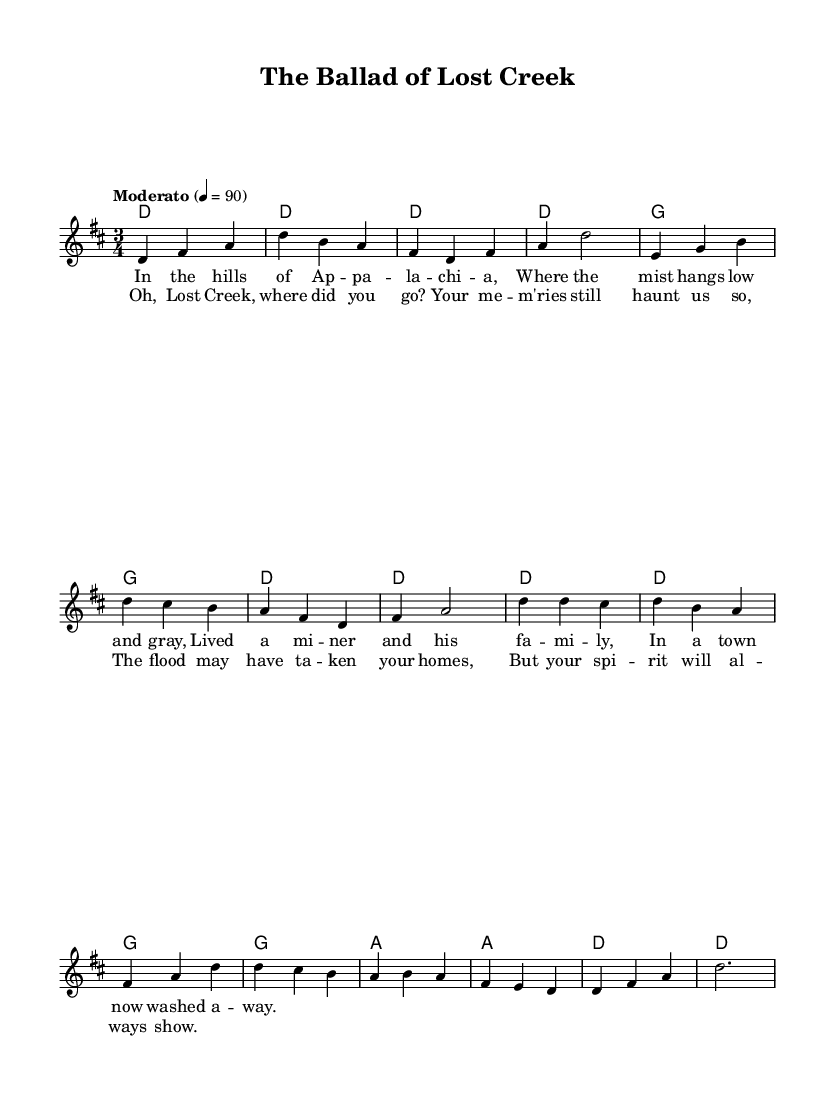What is the key signature of this music? The key signature is indicated at the beginning of the staff. It shows two sharps, which corresponds to D major.
Answer: D major What is the time signature of this music? The time signature is found at the start of the score, indicating the number of beats per measure. Here, it shows 3 over 4, meaning there are three beats in a measure and the quarter note gets one beat.
Answer: 3/4 What is the tempo marking for this piece? The tempo marking is often noted in the first part of the score. The marking "Moderato" is present, indicating a moderate speed of 90 beats per minute.
Answer: Moderato, 90 How many measures are in the verse section? The verse section is analyzed by counting the number of measures that contain the melody for the verses. There are eight measures in total in this section before it transitions to the chorus.
Answer: 8 What is the first note of the chorus? The first note of the chorus can be determined by examining the melody section to find the corresponding notes. The first note of the chorus is D.
Answer: D How does the harmony change during the chorus? The harmony is analyzed by looking at the chord progression provided under the chorus section. It moves from D major to G major and then A major before resolving back to D major, indicating a predominant progression typical in folk music.
Answer: D to G to A to D What story theme is presented in the lyrics? The lyrics of the song reveal a theme of loss and nostalgia, focusing on a town called Lost Creek that has been washed away, conveying emotional sentiments connected to memory and history.
Answer: Loss and nostalgia 